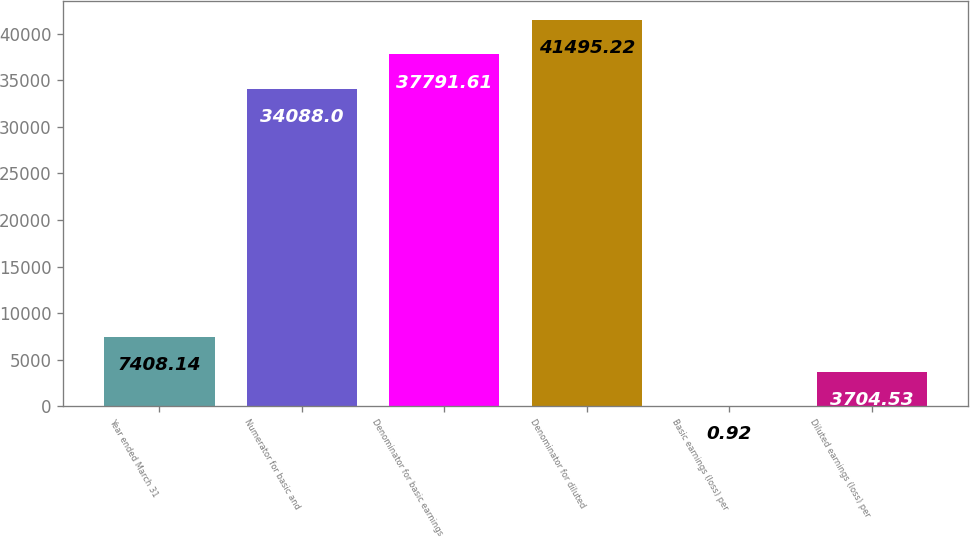Convert chart. <chart><loc_0><loc_0><loc_500><loc_500><bar_chart><fcel>Year ended March 31<fcel>Numerator for basic and<fcel>Denominator for basic earnings<fcel>Denominator for diluted<fcel>Basic earnings (loss) per<fcel>Diluted earnings (loss) per<nl><fcel>7408.14<fcel>34088<fcel>37791.6<fcel>41495.2<fcel>0.92<fcel>3704.53<nl></chart> 